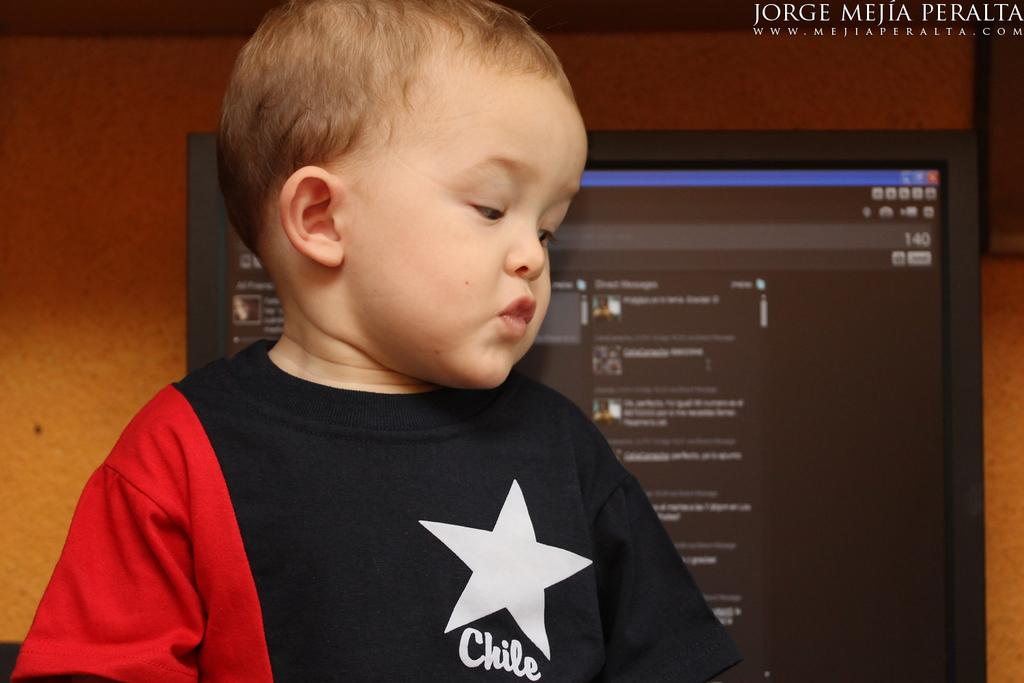Who is the main subject in the image? There is a boy in the image. What can be seen in the background of the image? There is a monitor and a wall in the background of the image. Can you describe any text visible in the image? Yes, there is some text visible in the image. How many pigs are visible in the image? There are no pigs present in the image. What is the temperature of the room in the image? The temperature of the room cannot be determined from the image. 